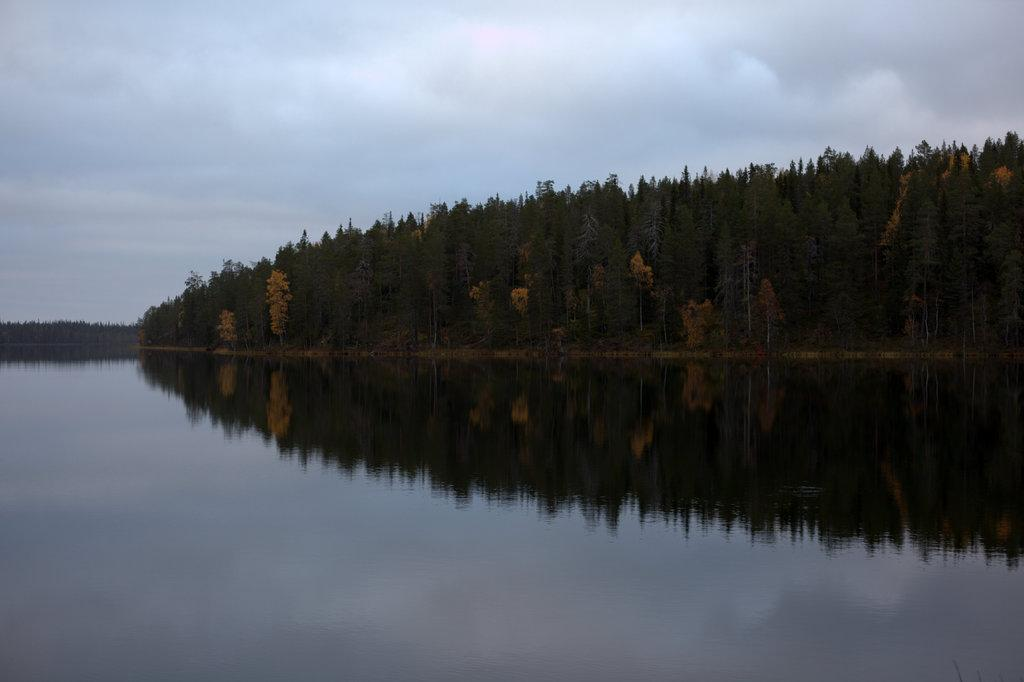What is in the foreground of the image? There is water in the foreground of the image. What can be seen in the water? There is a reflection of the sky, clouds, and trees in the water. What is visible at the back of the image? There are trees visible at the back of the image. What is visible at the top of the image? The sky is visible at the top of the image. What can be seen in the sky? There are clouds visible in the sky. How does the wealth of the people in the image affect the number of houses visible in the image? There are no houses or information about wealth present in the image. 